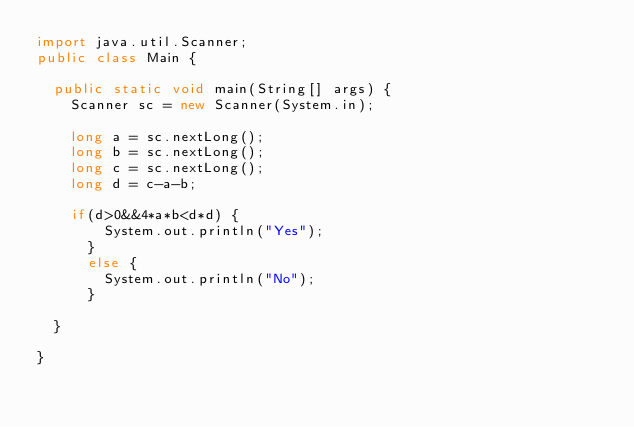<code> <loc_0><loc_0><loc_500><loc_500><_Java_>import java.util.Scanner;
public class Main {
 
	public static void main(String[] args) {
		Scanner sc = new Scanner(System.in);
 
		long a = sc.nextLong();
		long b = sc.nextLong();
		long c = sc.nextLong();
		long d = c-a-b;
		
		if(d>0&&4*a*b<d*d) {
				System.out.println("Yes");
			}
			else {
				System.out.println("No");
			}
		
	}
 
}</code> 